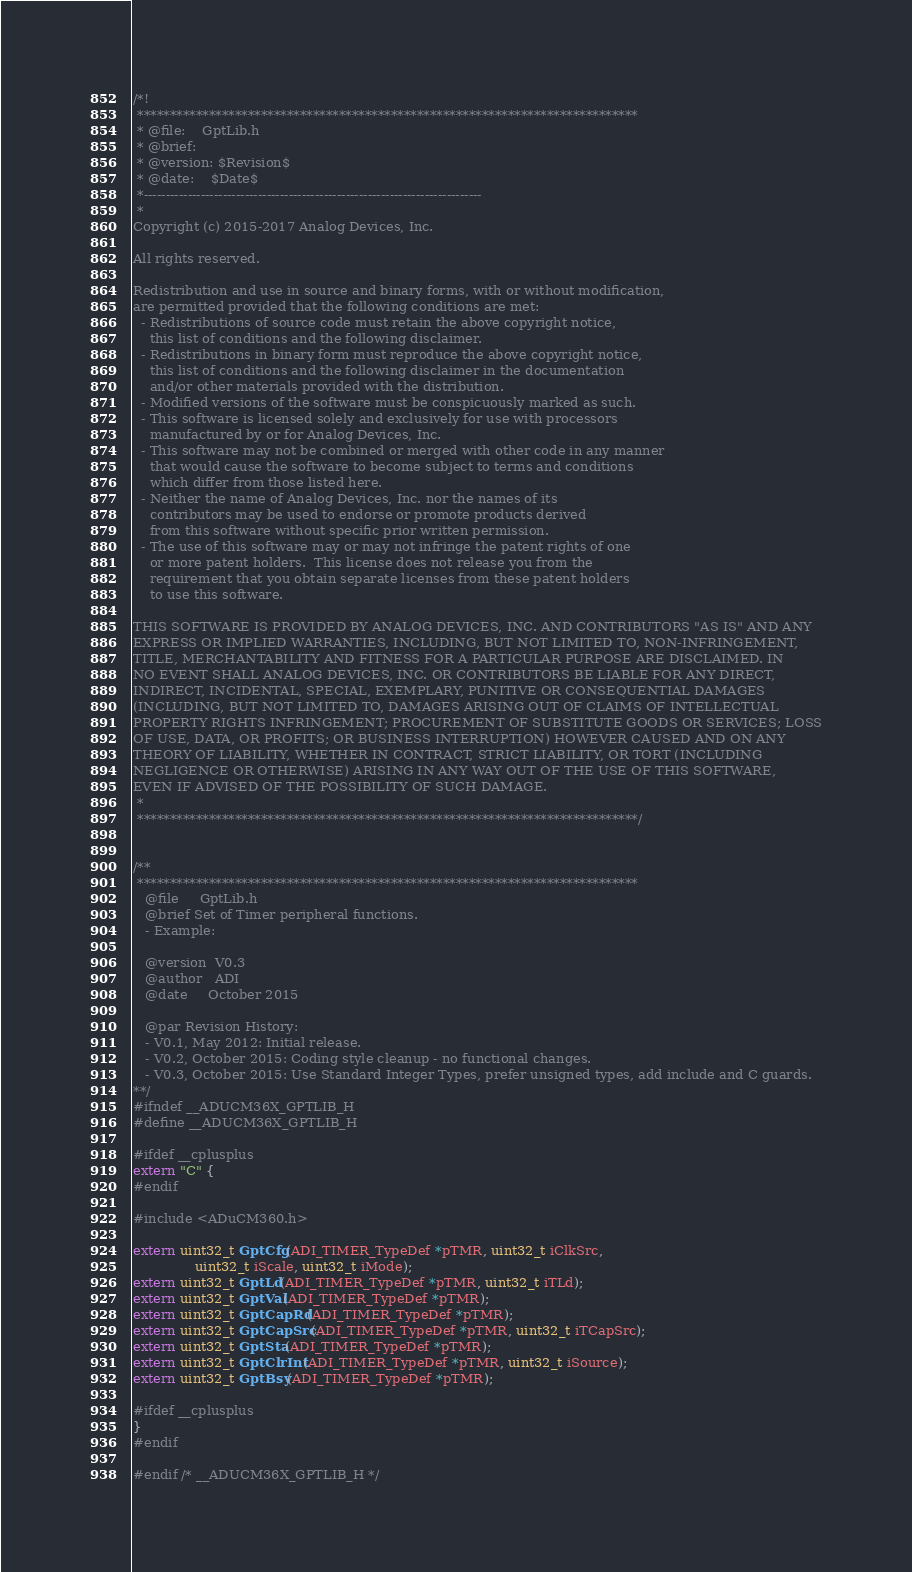<code> <loc_0><loc_0><loc_500><loc_500><_C_>/*!
 *****************************************************************************
 * @file:    GptLib.h
 * @brief:
 * @version: $Revision$
 * @date:    $Date$
 *-----------------------------------------------------------------------------
 *
Copyright (c) 2015-2017 Analog Devices, Inc.

All rights reserved.

Redistribution and use in source and binary forms, with or without modification,
are permitted provided that the following conditions are met:
  - Redistributions of source code must retain the above copyright notice,
    this list of conditions and the following disclaimer.
  - Redistributions in binary form must reproduce the above copyright notice,
    this list of conditions and the following disclaimer in the documentation
    and/or other materials provided with the distribution.
  - Modified versions of the software must be conspicuously marked as such.
  - This software is licensed solely and exclusively for use with processors
    manufactured by or for Analog Devices, Inc.
  - This software may not be combined or merged with other code in any manner
    that would cause the software to become subject to terms and conditions
    which differ from those listed here.
  - Neither the name of Analog Devices, Inc. nor the names of its
    contributors may be used to endorse or promote products derived
    from this software without specific prior written permission.
  - The use of this software may or may not infringe the patent rights of one
    or more patent holders.  This license does not release you from the
    requirement that you obtain separate licenses from these patent holders
    to use this software.

THIS SOFTWARE IS PROVIDED BY ANALOG DEVICES, INC. AND CONTRIBUTORS "AS IS" AND ANY
EXPRESS OR IMPLIED WARRANTIES, INCLUDING, BUT NOT LIMITED TO, NON-INFRINGEMENT,
TITLE, MERCHANTABILITY AND FITNESS FOR A PARTICULAR PURPOSE ARE DISCLAIMED. IN
NO EVENT SHALL ANALOG DEVICES, INC. OR CONTRIBUTORS BE LIABLE FOR ANY DIRECT,
INDIRECT, INCIDENTAL, SPECIAL, EXEMPLARY, PUNITIVE OR CONSEQUENTIAL DAMAGES
(INCLUDING, BUT NOT LIMITED TO, DAMAGES ARISING OUT OF CLAIMS OF INTELLECTUAL
PROPERTY RIGHTS INFRINGEMENT; PROCUREMENT OF SUBSTITUTE GOODS OR SERVICES; LOSS
OF USE, DATA, OR PROFITS; OR BUSINESS INTERRUPTION) HOWEVER CAUSED AND ON ANY
THEORY OF LIABILITY, WHETHER IN CONTRACT, STRICT LIABILITY, OR TORT (INCLUDING
NEGLIGENCE OR OTHERWISE) ARISING IN ANY WAY OUT OF THE USE OF THIS SOFTWARE,
EVEN IF ADVISED OF THE POSSIBILITY OF SUCH DAMAGE.
 *
 *****************************************************************************/


/**
 *****************************************************************************
   @file     GptLib.h
   @brief Set of Timer peripheral functions.
   - Example:

   @version  V0.3
   @author   ADI
   @date     October 2015

   @par Revision History:
   - V0.1, May 2012: Initial release.
   - V0.2, October 2015: Coding style cleanup - no functional changes.
   - V0.3, October 2015: Use Standard Integer Types, prefer unsigned types, add include and C guards.
**/
#ifndef __ADUCM36X_GPTLIB_H
#define __ADUCM36X_GPTLIB_H

#ifdef __cplusplus
extern "C" {
#endif

#include <ADuCM360.h>

extern uint32_t GptCfg(ADI_TIMER_TypeDef *pTMR, uint32_t iClkSrc,
		       uint32_t iScale, uint32_t iMode);
extern uint32_t GptLd(ADI_TIMER_TypeDef *pTMR, uint32_t iTLd);
extern uint32_t GptVal(ADI_TIMER_TypeDef *pTMR);
extern uint32_t GptCapRd(ADI_TIMER_TypeDef *pTMR);
extern uint32_t GptCapSrc(ADI_TIMER_TypeDef *pTMR, uint32_t iTCapSrc);
extern uint32_t GptSta(ADI_TIMER_TypeDef *pTMR);
extern uint32_t GptClrInt(ADI_TIMER_TypeDef *pTMR, uint32_t iSource);
extern uint32_t GptBsy(ADI_TIMER_TypeDef *pTMR);

#ifdef __cplusplus
}
#endif

#endif /* __ADUCM36X_GPTLIB_H */
</code> 